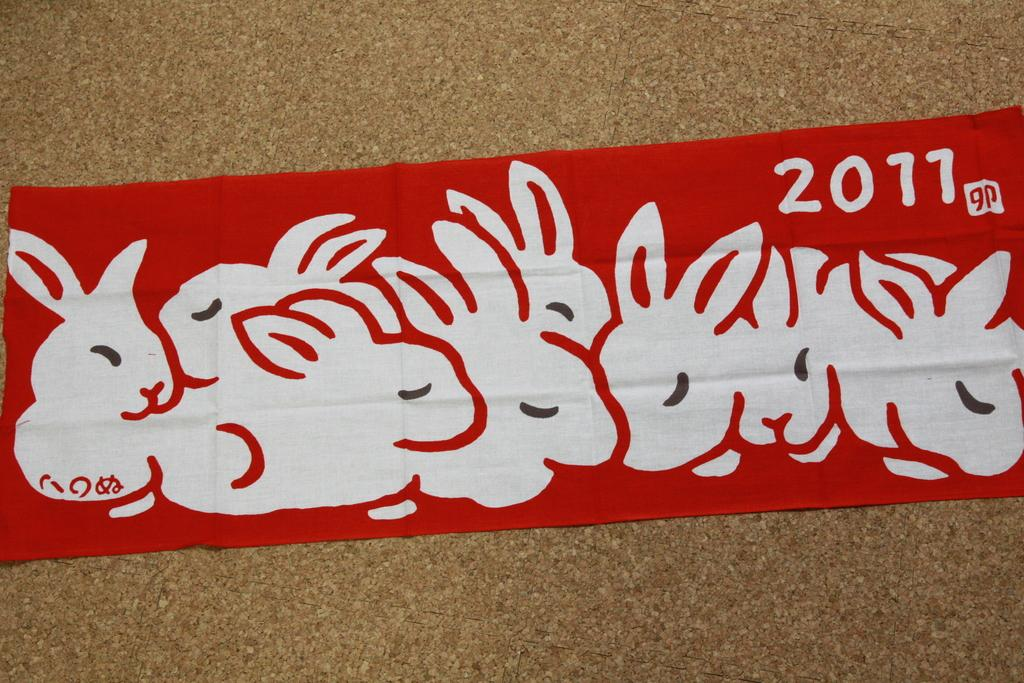What is the main subject in the image? There is a printed ribbon in the image. What type of snails can be seen participating in the competition in the image? There is no snail or competition present in the image; it only features a printed ribbon. 